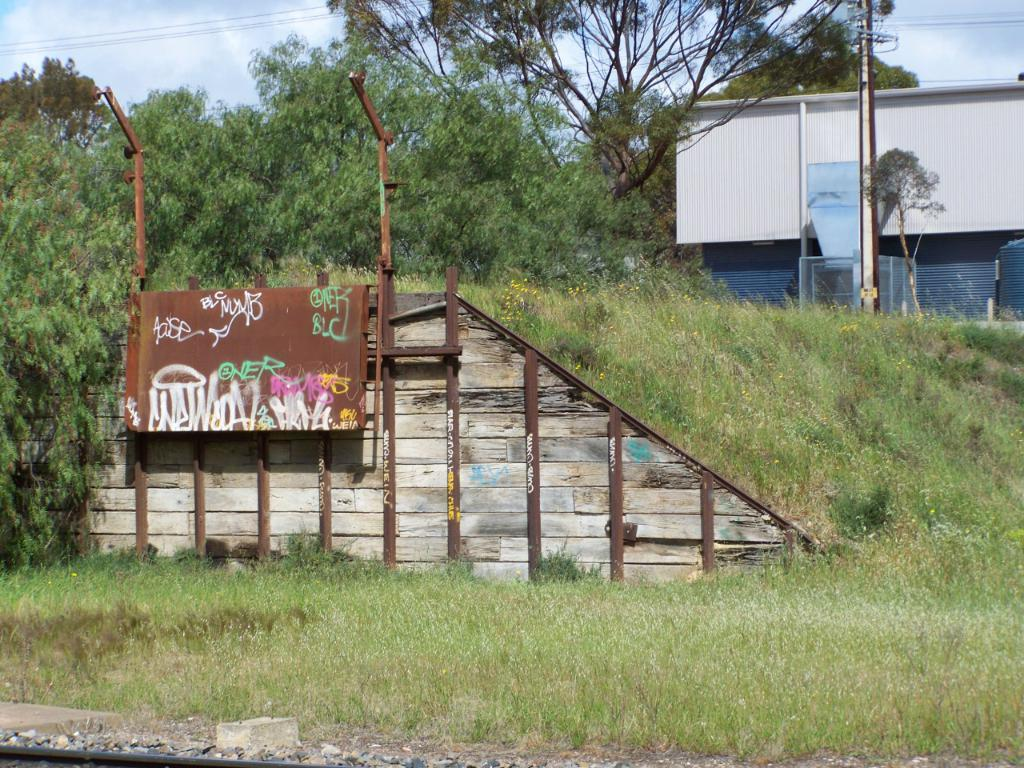What type of structures can be seen in the image? There are electric poles in the image. What is attached to the electric poles? There are electric lights and electric cables in the image. What type of natural environment is visible in the image? There is grass and trees visible in the image. What is visible in the sky in the image? The sky is visible in the image, and clouds are present. Where are the flowers and trucks located in the image? There are no flowers or trucks present in the image. What type of furniture can be seen in the bedroom in the image? There is no bedroom present in the image. 